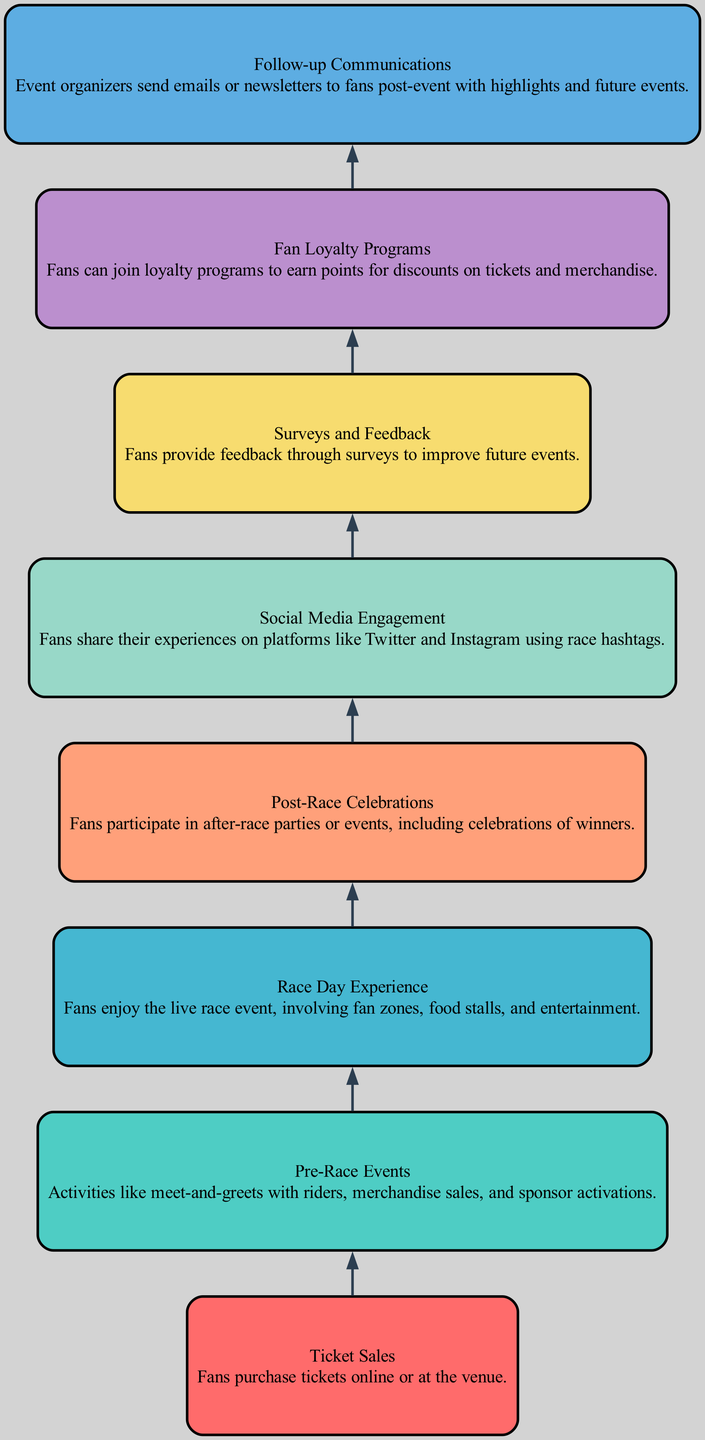What is the first activity listed in the diagram? The first activity is "Ticket Sales," as it is positioned at the top of the flow chart indicating the starting point of the fan engagement activities.
Answer: Ticket Sales Which activity comes immediately after "Race Day Experience"? The activity that comes immediately after "Race Day Experience" is "Post-Race Celebrations," as it follows directly in the sequence of activities in the diagram.
Answer: Post-Race Celebrations How many total activities are represented in the diagram? There are a total of eight activities listed in the diagram, as counted from the elements provided.
Answer: Eight What is the last activity shown in the flow chart? The last activity shown in the flow chart is "Follow-up Communications," as it is the bottom-most element in the diagram's structure.
Answer: Follow-up Communications Which two activities are grouped together that involve fan interactions after the race? The two activities grouped together that involve fan interactions after the race are "Post-Race Celebrations" and "Social Media Engagement," since they both relate to fan experiences following the main event.
Answer: Post-Race Celebrations and Social Media Engagement If a fan’s journey is analyzed, which activity is likely to generate feedback for future events? The activity likely to generate feedback for future events is "Surveys and Feedback," as it is directly related to collecting fan opinions and suggestions post-event for improvements.
Answer: Surveys and Feedback What type of engagement activity is involved with promotions for discounts? The engagement activity involved with promotions for discounts is "Fan Loyalty Programs," which is designed to reward fans with points that can be redeemed for discounts.
Answer: Fan Loyalty Programs Identify the relationship direction from "Pre-Race Events" to "Race Day Experience." The relationship direction from "Pre-Race Events" to "Race Day Experience" is that it flows downwards to indicate that pre-race activities lead into the main racing experience for fans.
Answer: Downwards 